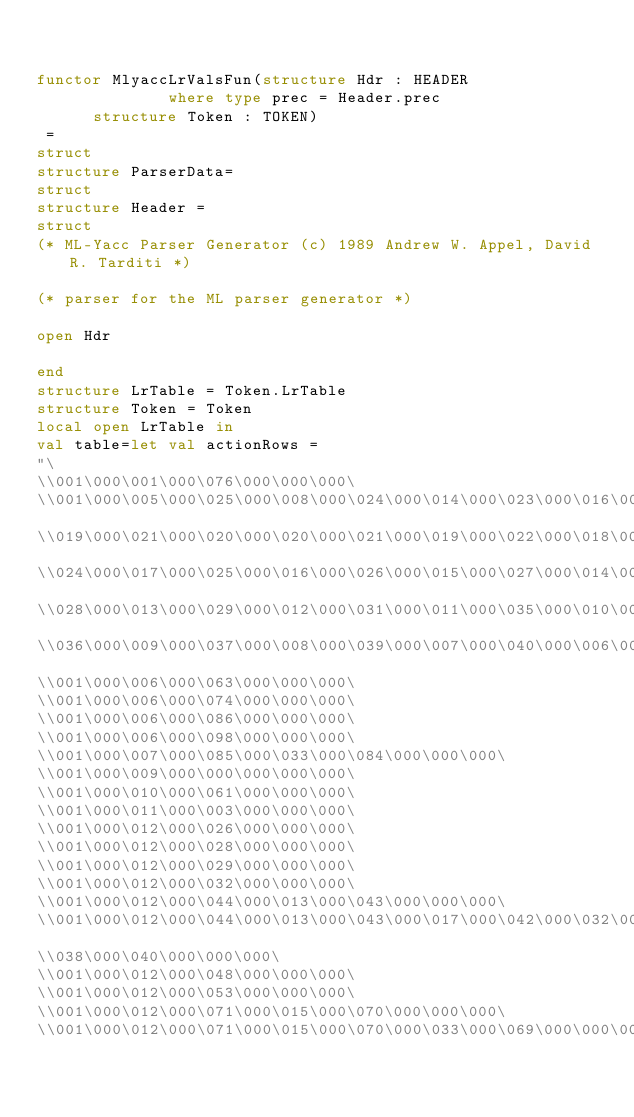Convert code to text. <code><loc_0><loc_0><loc_500><loc_500><_SML_>

functor MlyaccLrValsFun(structure Hdr : HEADER
		          where type prec = Header.prec
			structure Token : TOKEN)
 = 
struct
structure ParserData=
struct
structure Header = 
struct
(* ML-Yacc Parser Generator (c) 1989 Andrew W. Appel, David R. Tarditi *)

(* parser for the ML parser generator *)

open Hdr

end
structure LrTable = Token.LrTable
structure Token = Token
local open LrTable in 
val table=let val actionRows =
"\
\\001\000\001\000\076\000\000\000\
\\001\000\005\000\025\000\008\000\024\000\014\000\023\000\016\000\022\000\
\\019\000\021\000\020\000\020\000\021\000\019\000\022\000\018\000\
\\024\000\017\000\025\000\016\000\026\000\015\000\027\000\014\000\
\\028\000\013\000\029\000\012\000\031\000\011\000\035\000\010\000\
\\036\000\009\000\037\000\008\000\039\000\007\000\040\000\006\000\000\000\
\\001\000\006\000\063\000\000\000\
\\001\000\006\000\074\000\000\000\
\\001\000\006\000\086\000\000\000\
\\001\000\006\000\098\000\000\000\
\\001\000\007\000\085\000\033\000\084\000\000\000\
\\001\000\009\000\000\000\000\000\
\\001\000\010\000\061\000\000\000\
\\001\000\011\000\003\000\000\000\
\\001\000\012\000\026\000\000\000\
\\001\000\012\000\028\000\000\000\
\\001\000\012\000\029\000\000\000\
\\001\000\012\000\032\000\000\000\
\\001\000\012\000\044\000\013\000\043\000\000\000\
\\001\000\012\000\044\000\013\000\043\000\017\000\042\000\032\000\041\000\
\\038\000\040\000\000\000\
\\001\000\012\000\048\000\000\000\
\\001\000\012\000\053\000\000\000\
\\001\000\012\000\071\000\015\000\070\000\000\000\
\\001\000\012\000\071\000\015\000\070\000\033\000\069\000\000\000\</code> 